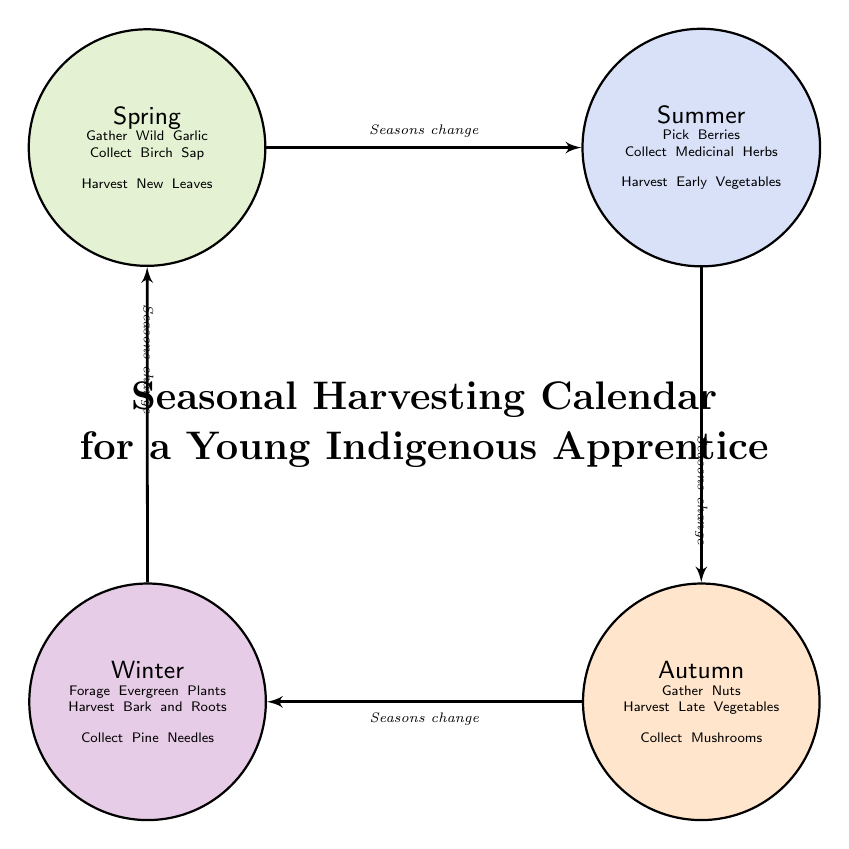What is the first season listed in the diagram? The diagram starts with 'Spring' as the first node in the seasonal cycle.
Answer: Spring How many activities are listed for Summer? In the Summer node, there are three activities specified: Pick Berries, Collect Medicinal Herbs, and Harvest Early Vegetables.
Answer: 3 What activity is associated with Autumn? Autumn has three activities including 'Gather Nuts', 'Harvest Late Vegetables', and 'Collect Mushrooms', so either of these can be a correct response. I will select 'Gather Nuts' as one example.
Answer: Gather Nuts Which season follows Winter? According to the flow connections in the diagram, after Winter, the next season is Spring.
Answer: Spring How many total nodes are there in the diagram? The diagram has four nodes: Spring, Summer, Autumn, and Winter, thus totaling four.
Answer: 4 Which season has the activity 'Collect Birch Sap'? The activity 'Collect Birch Sap' is listed under the Spring node, indicating that it is associated with that season.
Answer: Spring What is the connection type described in the diagram? The connections between the seasons are described as "Seasons change," indicating the cyclical nature of the seasonal transitions in the chart.
Answer: Seasons change Which is the last season in the diagram? The last season in the cycle is Winter, which connects back to Spring to complete the cycle.
Answer: Winter 